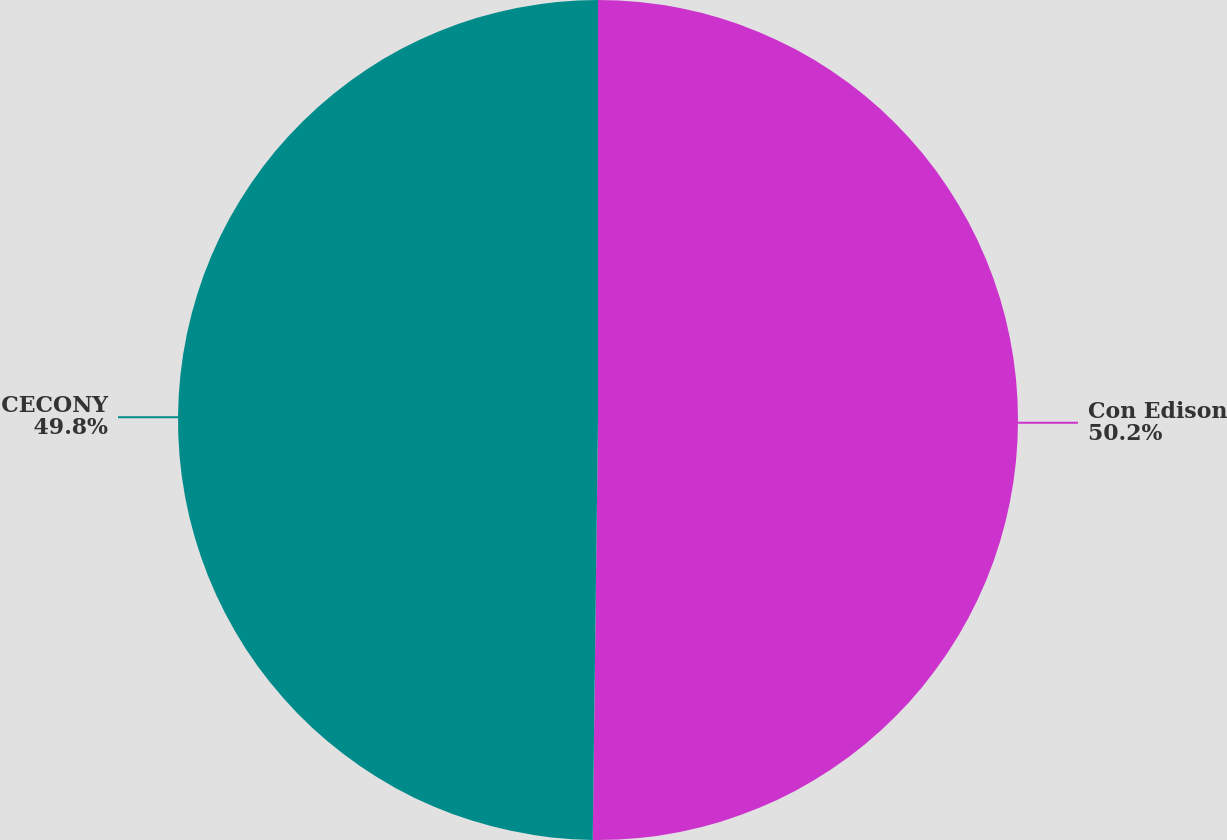Convert chart. <chart><loc_0><loc_0><loc_500><loc_500><pie_chart><fcel>Con Edison<fcel>CECONY<nl><fcel>50.2%<fcel>49.8%<nl></chart> 